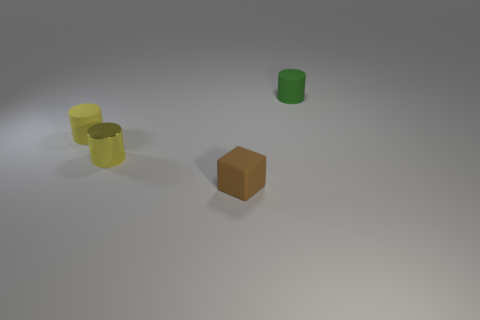What is the lighting like in the scene? The lighting in the image is soft and diffused, emanating from the upper right, which casts gentle shadows on the left sides of the objects, giving the scene a calm and uniform look. 